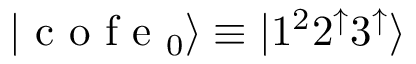<formula> <loc_0><loc_0><loc_500><loc_500>| c o f e _ { 0 } \rangle \equiv | 1 ^ { 2 } 2 ^ { \uparrow } 3 ^ { \uparrow } \rangle</formula> 